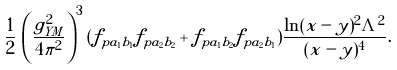Convert formula to latex. <formula><loc_0><loc_0><loc_500><loc_500>\frac { 1 } { 2 } \, \left ( \frac { g ^ { 2 } _ { Y M } } { 4 \pi ^ { 2 } } \right ) ^ { 3 } ( f _ { p a _ { 1 } b _ { 1 } } f _ { p a _ { 2 } b _ { 2 } } + f _ { p a _ { 1 } b _ { 2 } } f _ { p a _ { 2 } b _ { 1 } } ) \frac { \ln ( x - y ) ^ { 2 } \Lambda ^ { 2 } } { ( x - y ) ^ { 4 } } .</formula> 